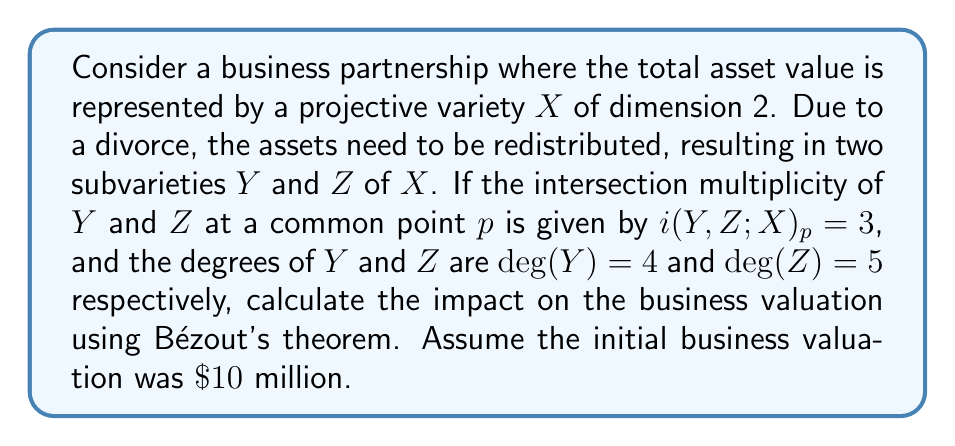Teach me how to tackle this problem. To solve this problem, we'll use intersection theory and Bézout's theorem:

1) Bézout's theorem states that for two subvarieties $Y$ and $Z$ of a projective space:

   $$\sum_{p \in Y \cap Z} i(Y,Z;X)_p = \deg(Y) \cdot \deg(Z)$$

2) We're given:
   - $i(Y,Z;X)_p = 3$ at one point
   - $\deg(Y) = 4$
   - $\deg(Z) = 5$

3) Let's calculate the total number of intersection points:

   $$\deg(Y) \cdot \deg(Z) = 4 \cdot 5 = 20$$

4) If one point has multiplicity 3, and assuming all other points have multiplicity 1:

   $$3 + (n-1) \cdot 1 = 20$$
   $$n = 18$$

   Where $n$ is the total number of intersection points.

5) These 18 points represent the areas where the asset redistribution affects the business.

6) To calculate the impact on valuation, we can use the ratio of affected points to total possible intersections:

   $$\text{Impact Ratio} = \frac{18}{20} = 0.9$$

7) Assuming this ratio directly correlates to the business valuation:

   $$\text{New Valuation} = \$10\text{ million} \cdot (1 - 0.9) = \$1\text{ million}$$

Therefore, the new business valuation after asset redistribution is $\$1$ million.
Answer: $\$1$ million 